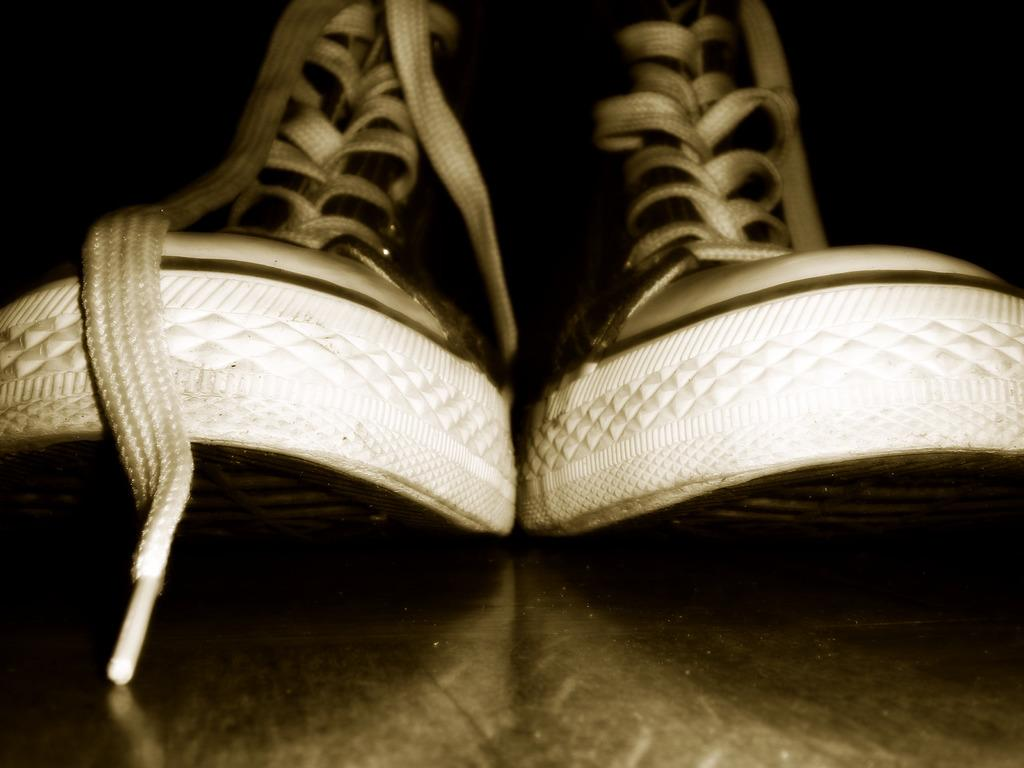What objects are in the image? There are shoes in the image. What can be seen in the background of the image? The background of the image is dark. What type of meal is being prepared on the roof in the image? There is no reference to a meal or a roof in the image, so it's not possible to answer that question. 